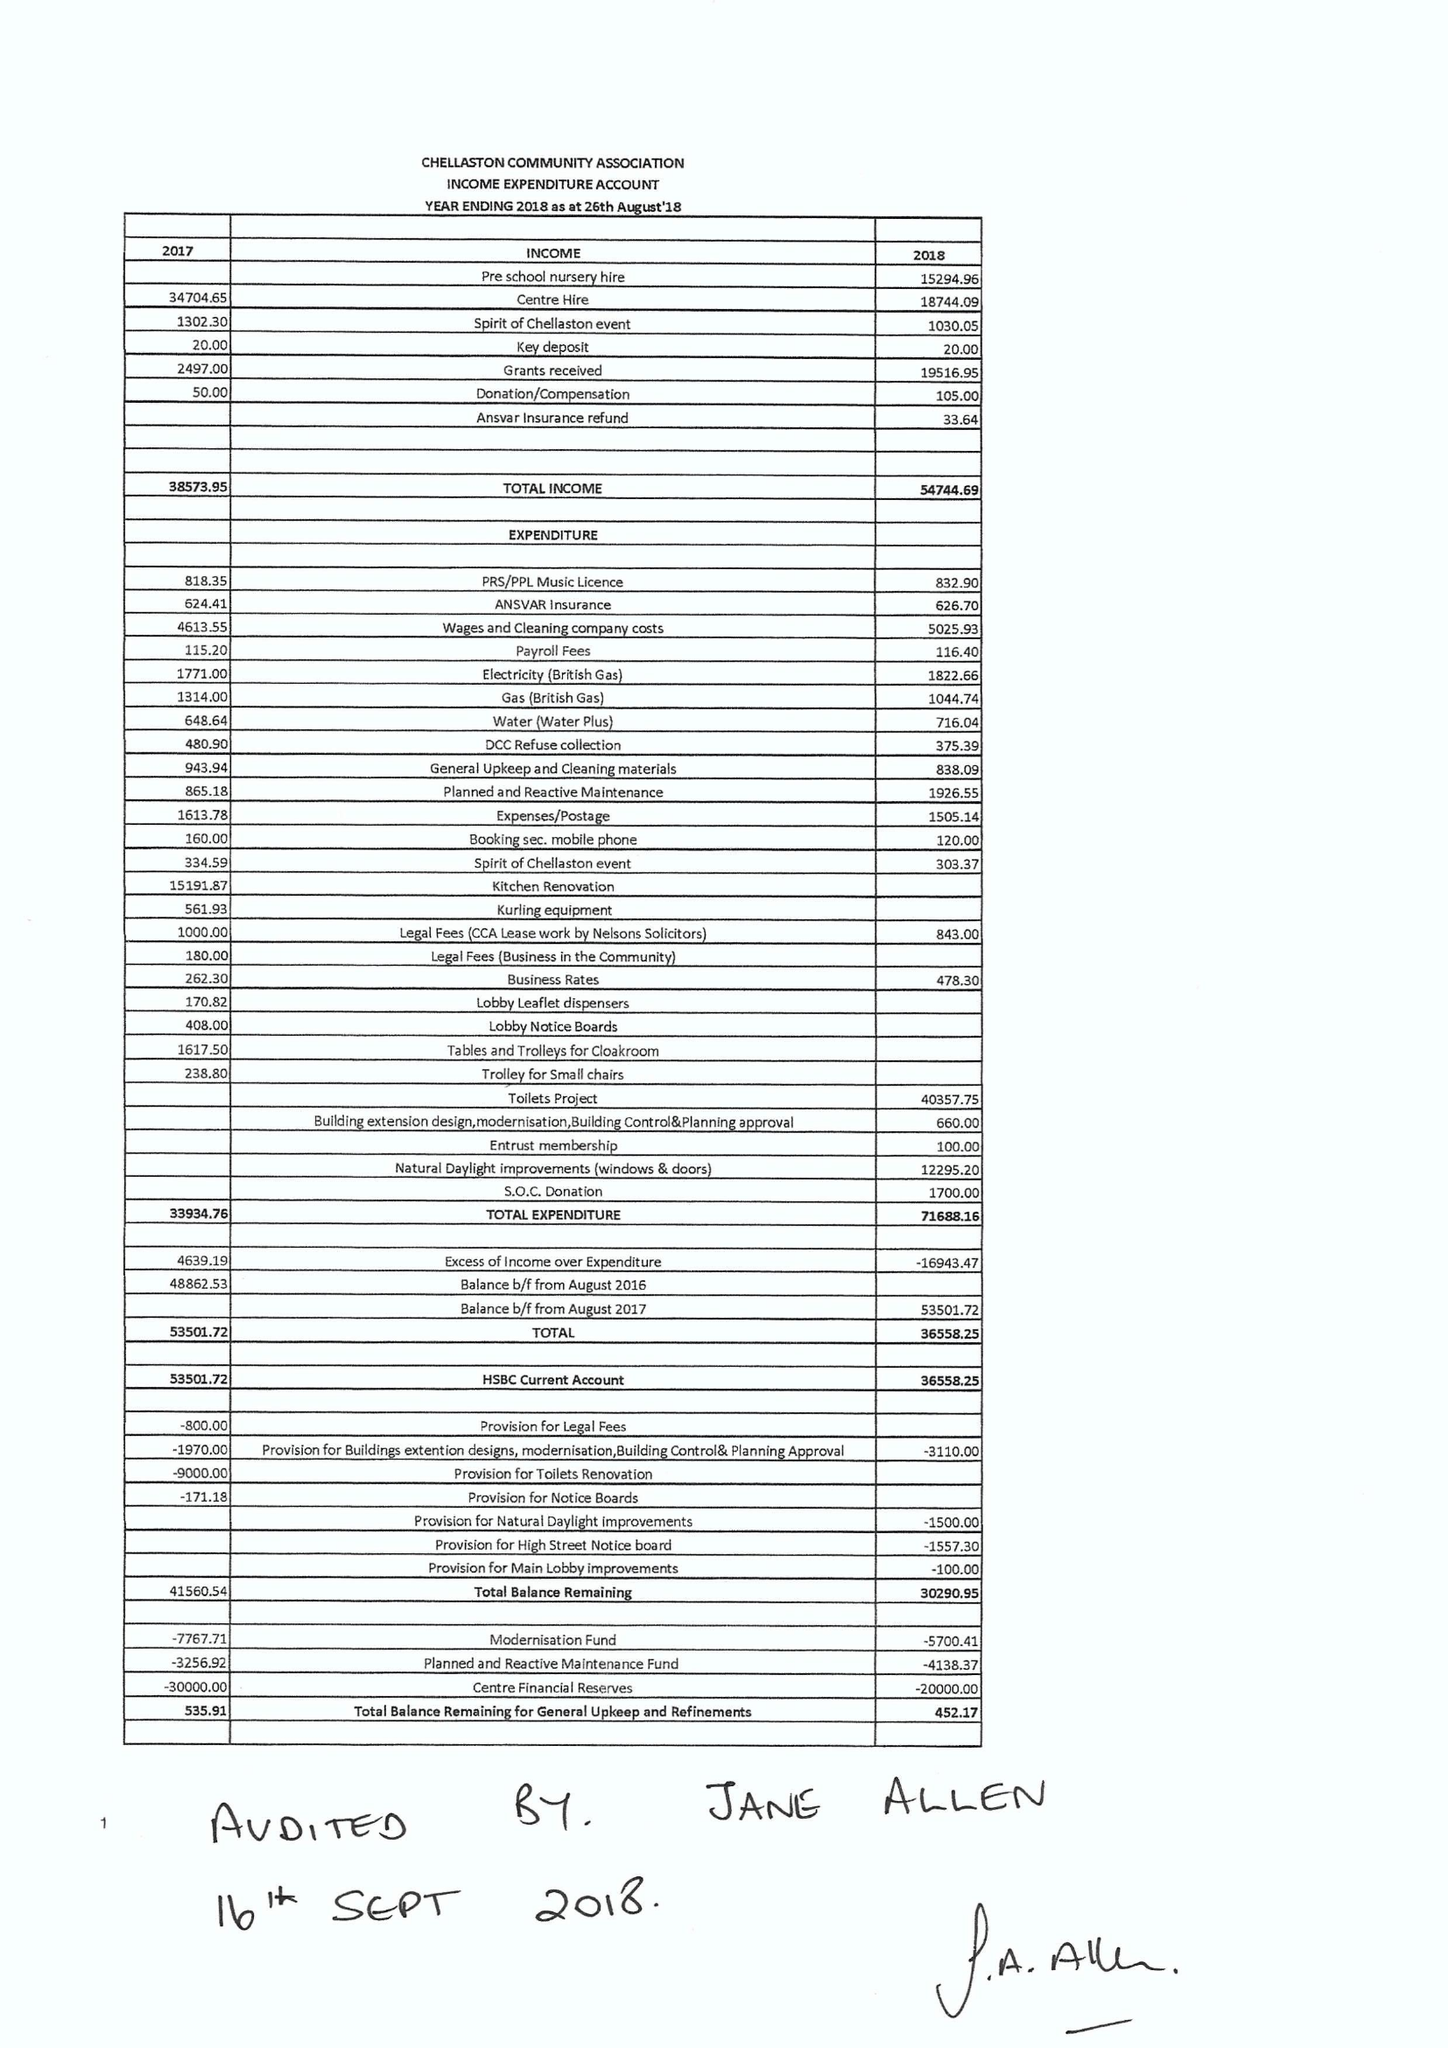What is the value for the address__street_line?
Answer the question using a single word or phrase. 68 PARKWAY 